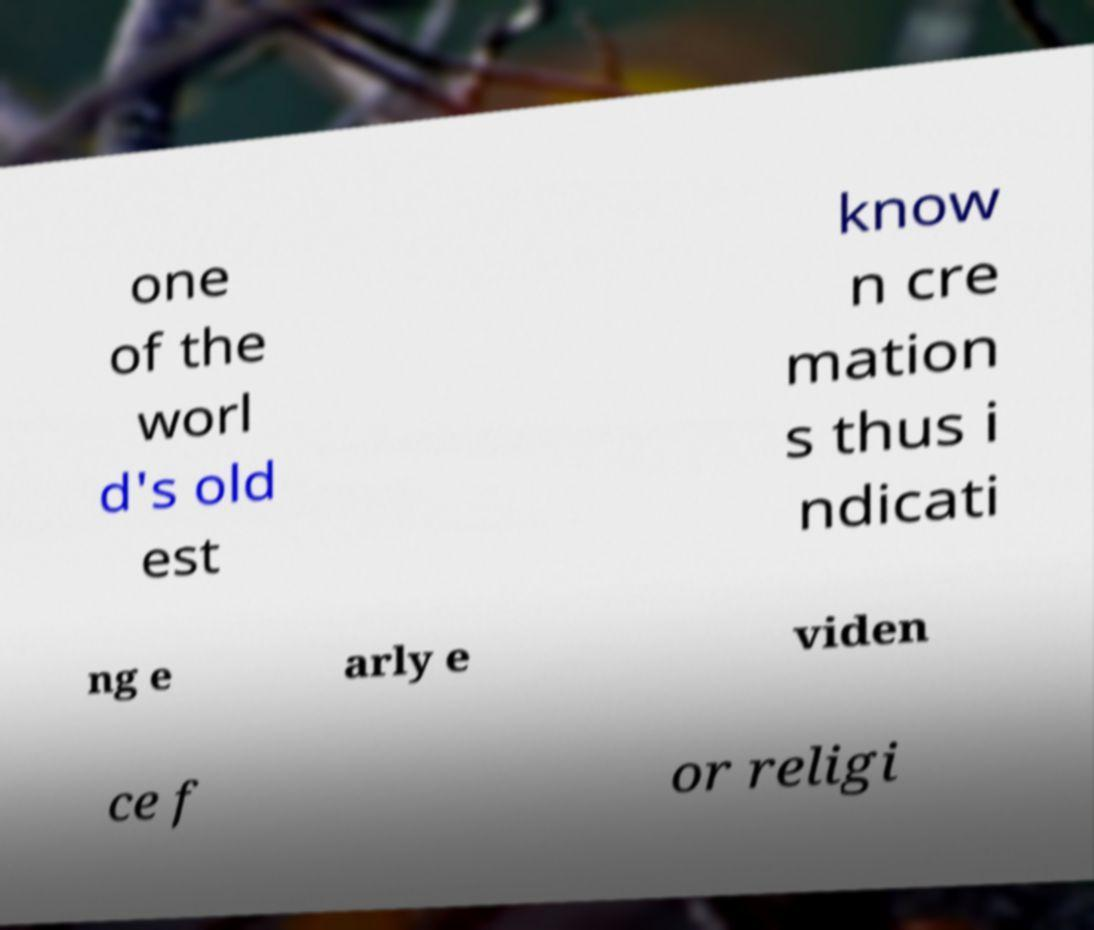Please read and relay the text visible in this image. What does it say? one of the worl d's old est know n cre mation s thus i ndicati ng e arly e viden ce f or religi 